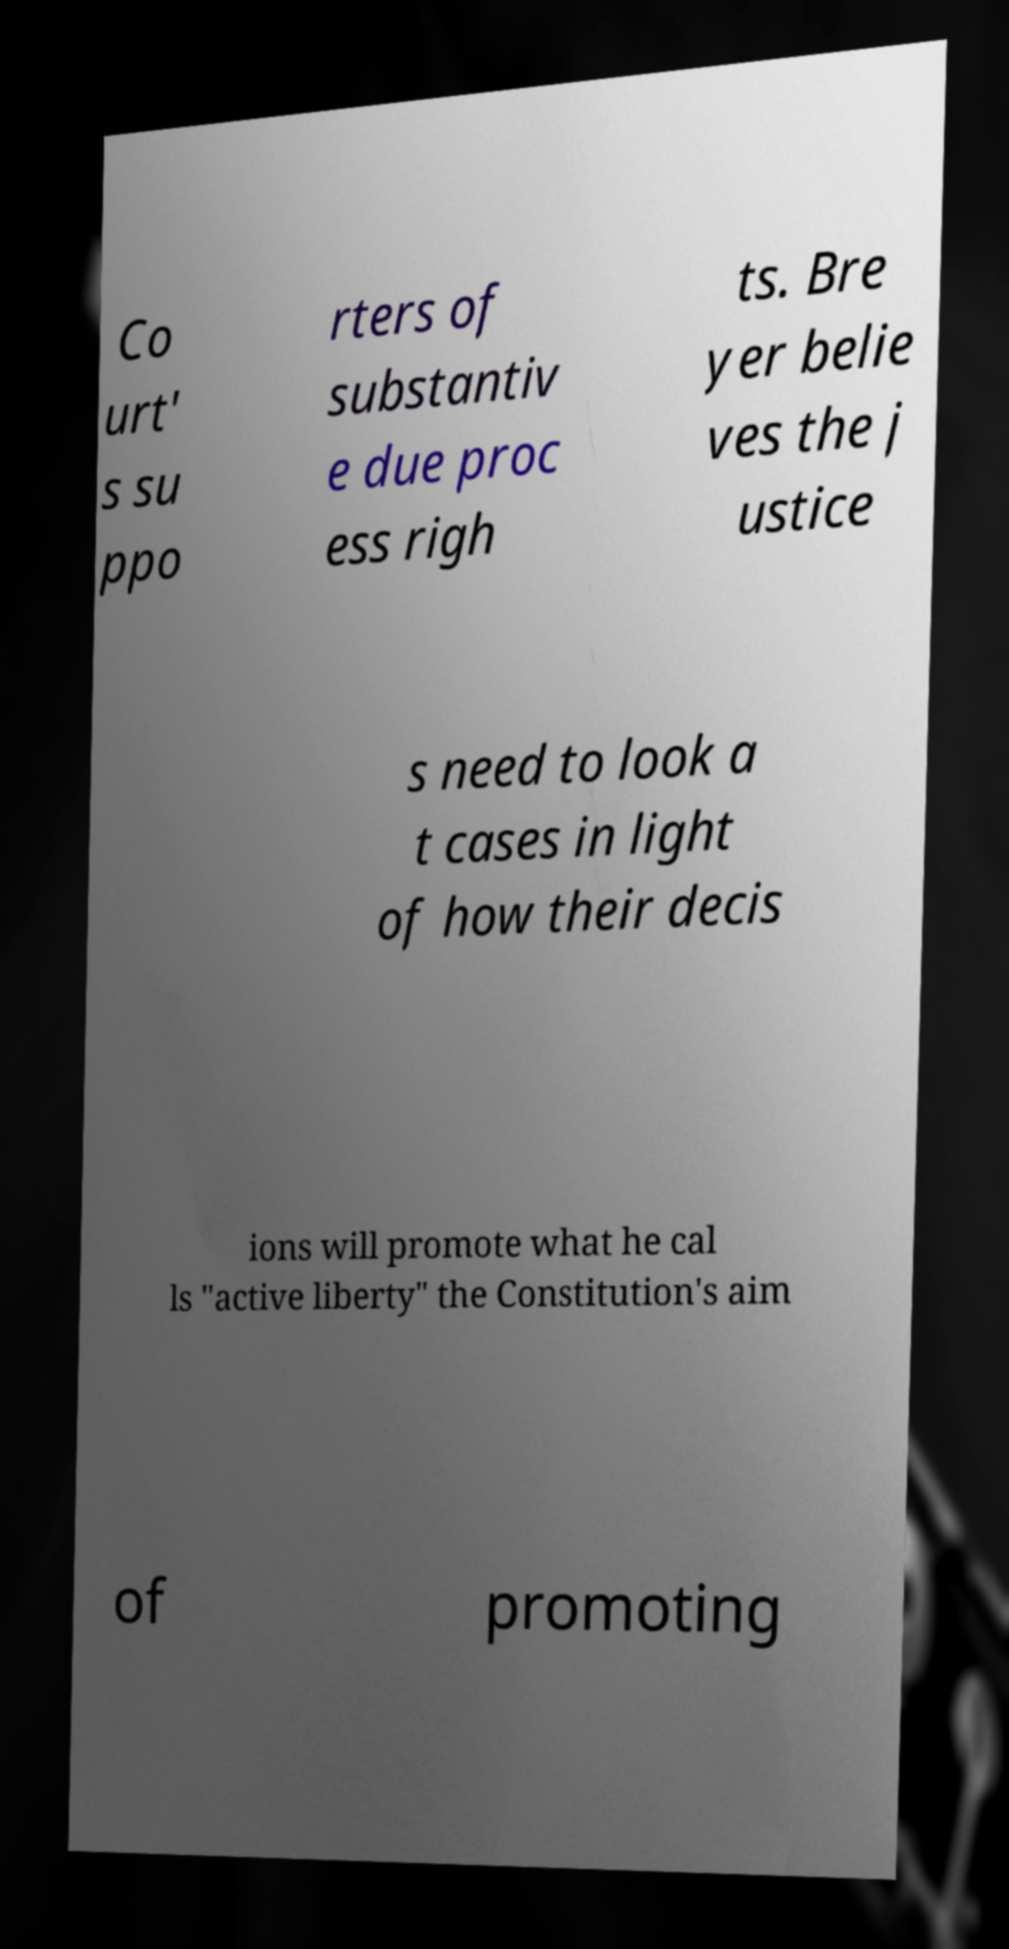Please identify and transcribe the text found in this image. Co urt' s su ppo rters of substantiv e due proc ess righ ts. Bre yer belie ves the j ustice s need to look a t cases in light of how their decis ions will promote what he cal ls "active liberty" the Constitution's aim of promoting 